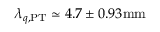Convert formula to latex. <formula><loc_0><loc_0><loc_500><loc_500>\lambda _ { q , { P T } } \simeq 4 . 7 \pm 0 . 9 3 { m m }</formula> 